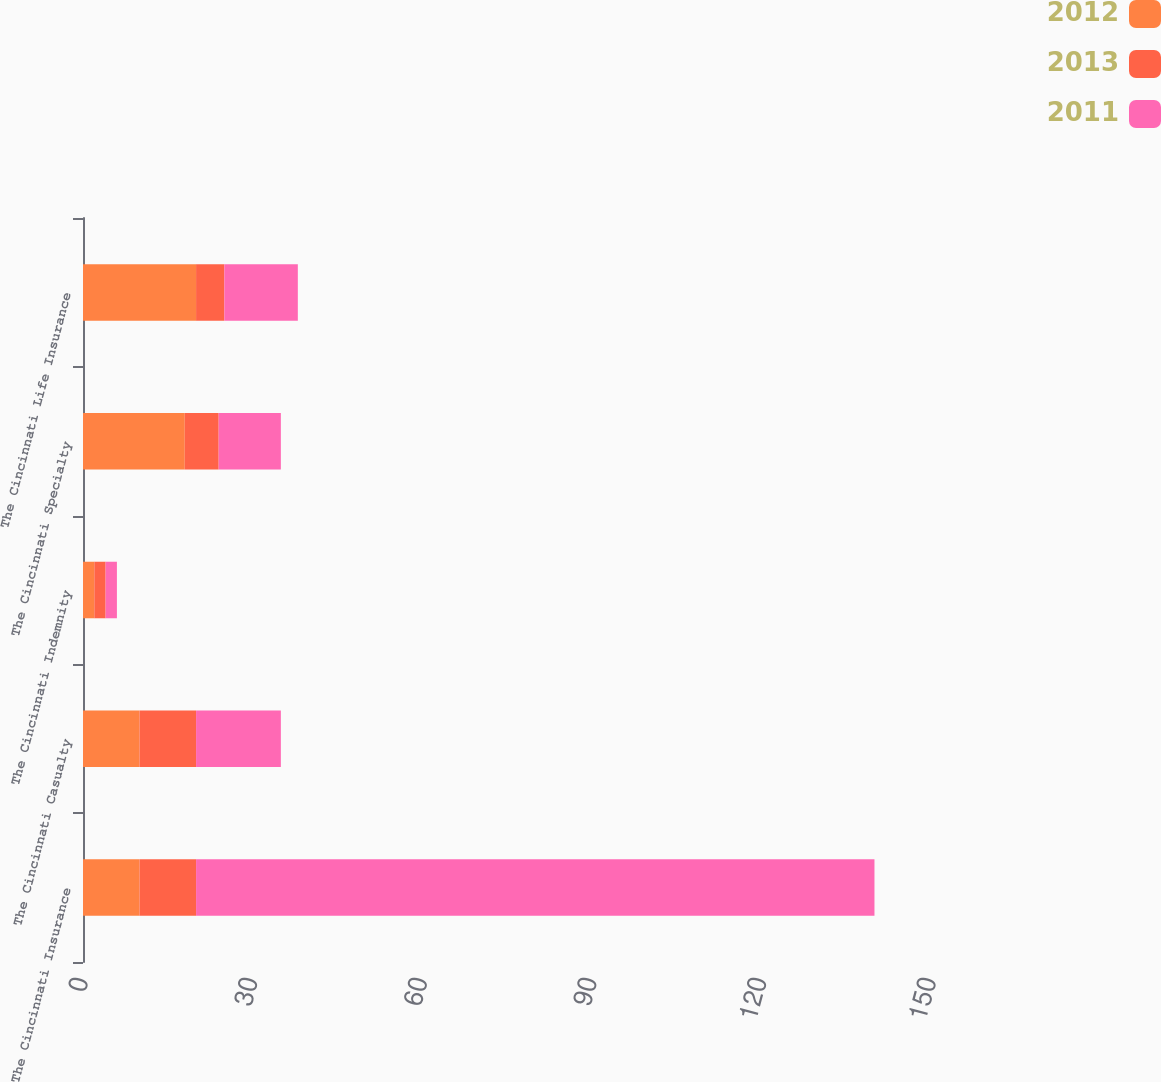Convert chart to OTSL. <chart><loc_0><loc_0><loc_500><loc_500><stacked_bar_chart><ecel><fcel>The Cincinnati Insurance<fcel>The Cincinnati Casualty<fcel>The Cincinnati Indemnity<fcel>The Cincinnati Specialty<fcel>The Cincinnati Life Insurance<nl><fcel>2012<fcel>10<fcel>10<fcel>2<fcel>18<fcel>20<nl><fcel>2013<fcel>10<fcel>10<fcel>2<fcel>6<fcel>5<nl><fcel>2011<fcel>120<fcel>15<fcel>2<fcel>11<fcel>13<nl></chart> 